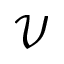Convert formula to latex. <formula><loc_0><loc_0><loc_500><loc_500>\mathcal { V }</formula> 